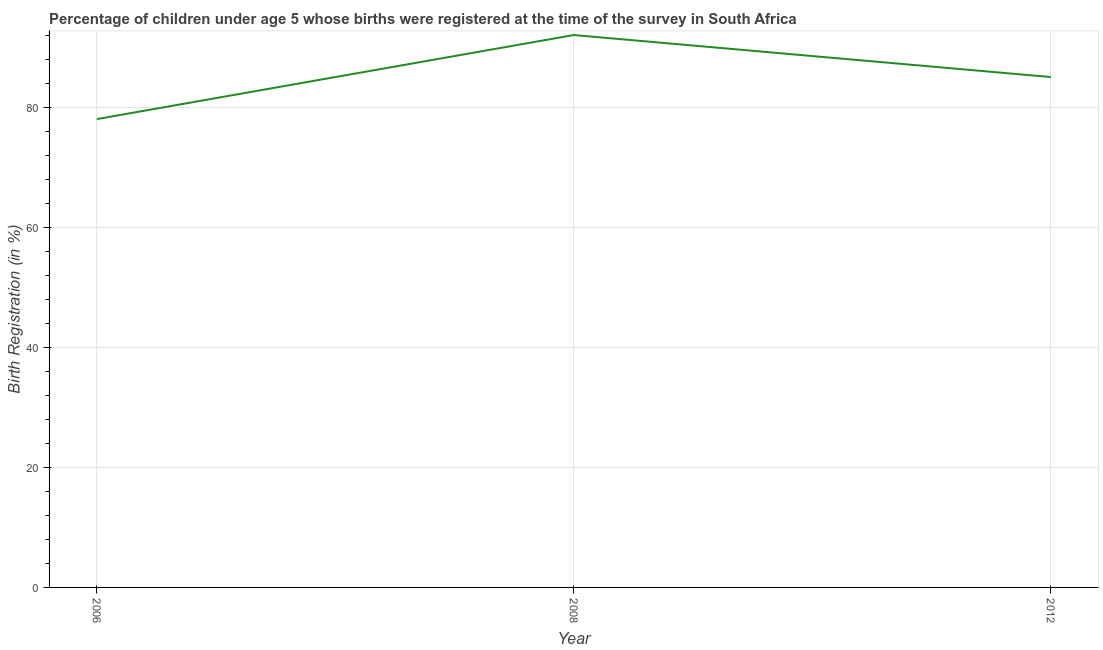What is the birth registration in 2012?
Make the answer very short. 85. Across all years, what is the maximum birth registration?
Make the answer very short. 92. Across all years, what is the minimum birth registration?
Offer a terse response. 78. In which year was the birth registration maximum?
Ensure brevity in your answer.  2008. What is the sum of the birth registration?
Your answer should be compact. 255. What is the difference between the birth registration in 2008 and 2012?
Offer a terse response. 7. In how many years, is the birth registration greater than 20 %?
Your response must be concise. 3. What is the ratio of the birth registration in 2006 to that in 2012?
Ensure brevity in your answer.  0.92. Is the difference between the birth registration in 2006 and 2008 greater than the difference between any two years?
Give a very brief answer. Yes. What is the difference between the highest and the second highest birth registration?
Keep it short and to the point. 7. What is the difference between the highest and the lowest birth registration?
Offer a terse response. 14. In how many years, is the birth registration greater than the average birth registration taken over all years?
Keep it short and to the point. 1. How many lines are there?
Make the answer very short. 1. How many years are there in the graph?
Offer a very short reply. 3. What is the difference between two consecutive major ticks on the Y-axis?
Your answer should be compact. 20. What is the title of the graph?
Provide a short and direct response. Percentage of children under age 5 whose births were registered at the time of the survey in South Africa. What is the label or title of the X-axis?
Your answer should be very brief. Year. What is the label or title of the Y-axis?
Make the answer very short. Birth Registration (in %). What is the Birth Registration (in %) in 2006?
Your answer should be compact. 78. What is the Birth Registration (in %) in 2008?
Give a very brief answer. 92. What is the difference between the Birth Registration (in %) in 2006 and 2008?
Ensure brevity in your answer.  -14. What is the ratio of the Birth Registration (in %) in 2006 to that in 2008?
Ensure brevity in your answer.  0.85. What is the ratio of the Birth Registration (in %) in 2006 to that in 2012?
Your answer should be compact. 0.92. What is the ratio of the Birth Registration (in %) in 2008 to that in 2012?
Your response must be concise. 1.08. 